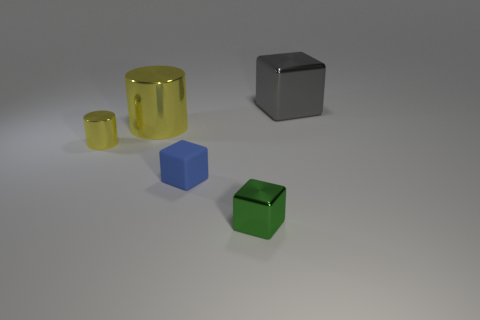Is the big shiny block the same color as the small rubber cube? no 